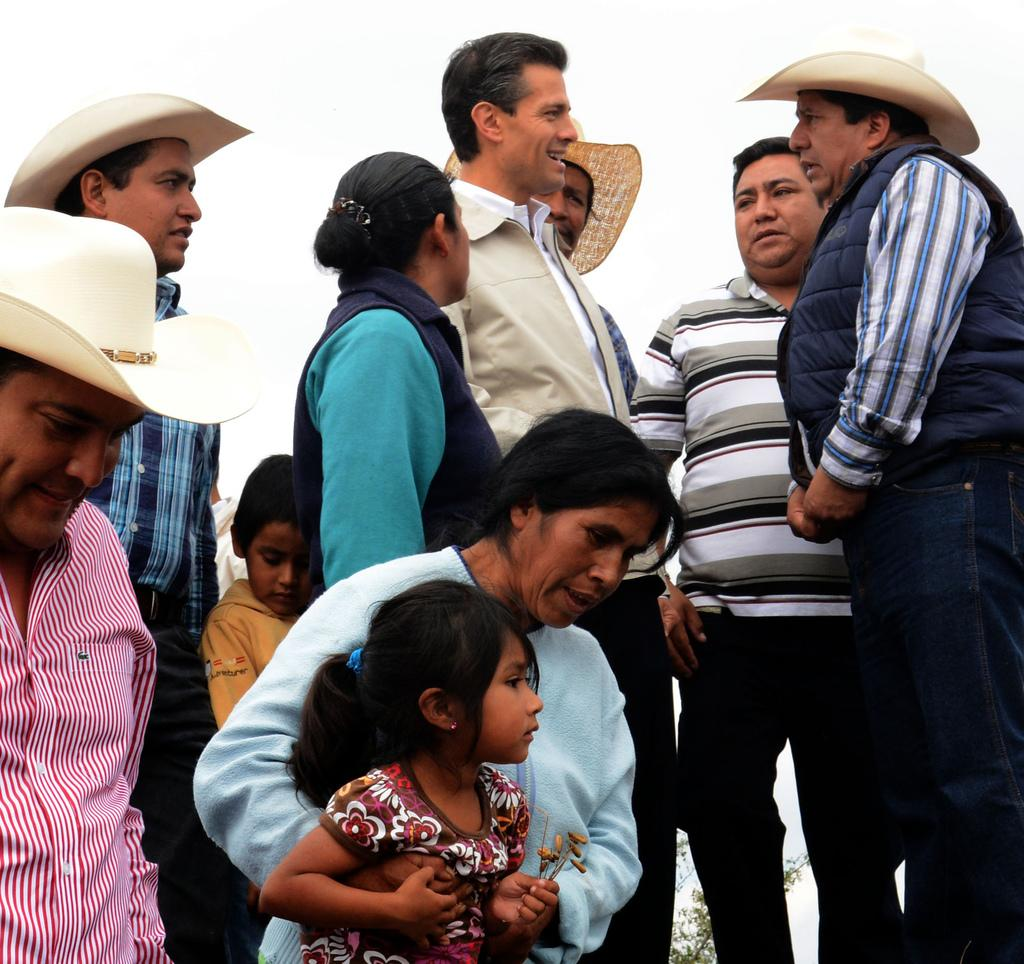How many people are in the image? There are persons in the image, but the exact number is not specified. What can be seen in the background of the image? There are plants and the sky visible in the background of the image. What type of bun is being used to hold the picture in the image? There is no picture or bun present in the image. Is there a chain attached to the persons in the image? There is no mention of a chain or any attachment to the persons in the image. 